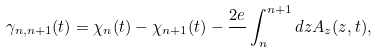<formula> <loc_0><loc_0><loc_500><loc_500>\gamma _ { n , n + 1 } ( t ) = \chi _ { n } ( t ) - \chi _ { n + 1 } ( t ) - \frac { 2 e } { } \int _ { n } ^ { n + 1 } d z A _ { z } ( z , t ) ,</formula> 